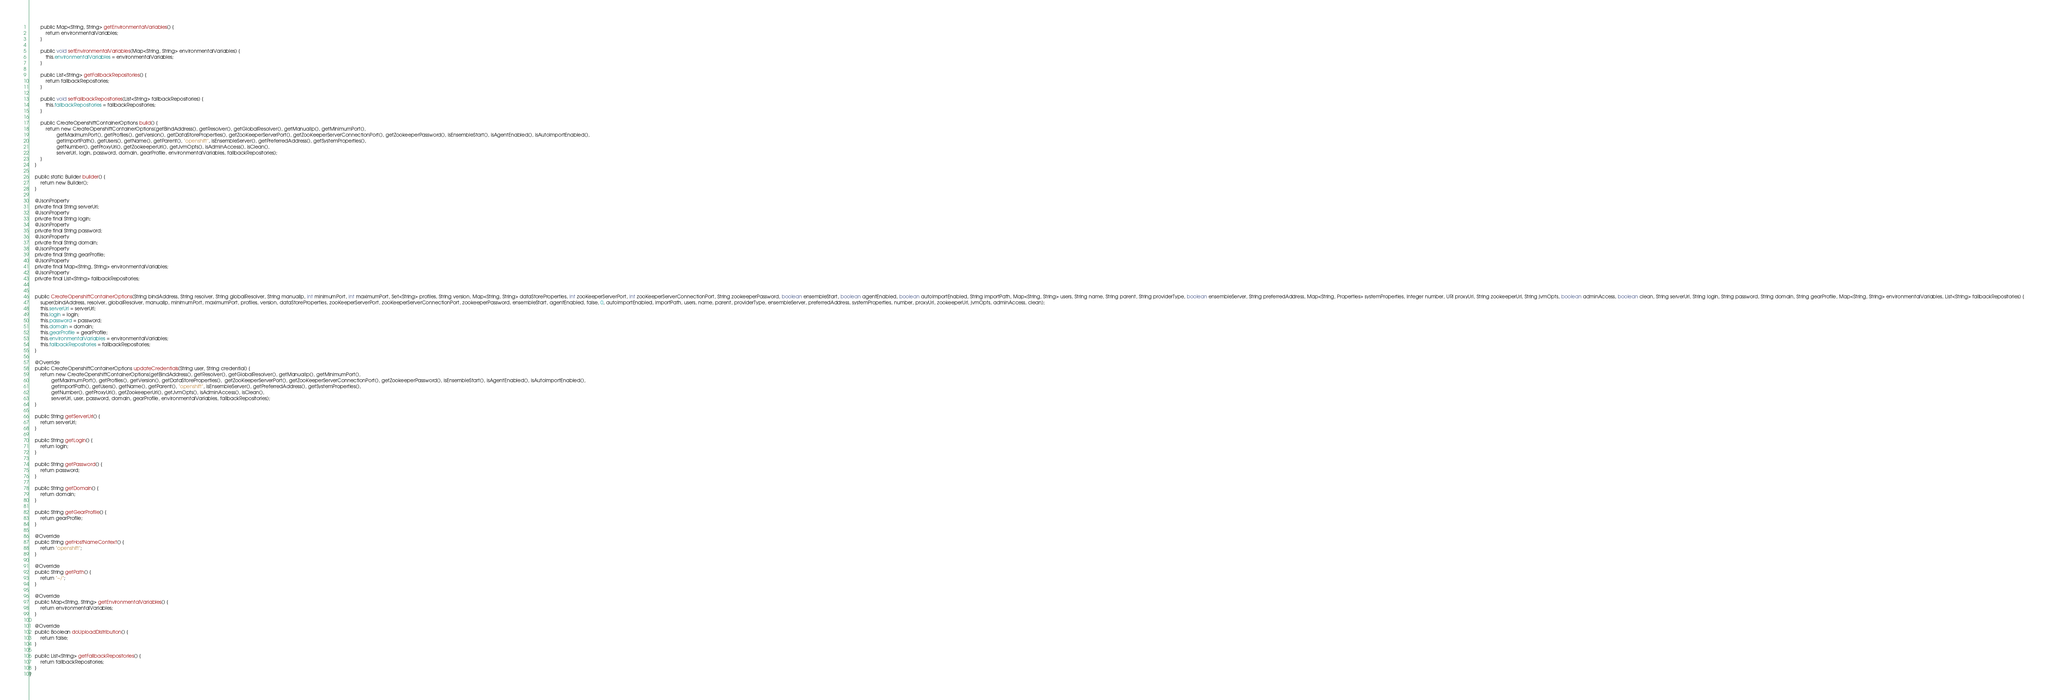<code> <loc_0><loc_0><loc_500><loc_500><_Java_>        public Map<String, String> getEnvironmentalVariables() {
            return environmentalVariables;
        }

        public void setEnvironmentalVariables(Map<String, String> environmentalVariables) {
            this.environmentalVariables = environmentalVariables;
        }

        public List<String> getFallbackRepositories() {
            return fallbackRepositories;
        }

        public void setFallbackRepositories(List<String> fallbackRepositories) {
            this.fallbackRepositories = fallbackRepositories;
        }

        public CreateOpenshiftContainerOptions build() {
            return new CreateOpenshiftContainerOptions(getBindAddress(), getResolver(), getGlobalResolver(), getManualIp(), getMinimumPort(),
                    getMaximumPort(), getProfiles(), getVersion(), getDataStoreProperties(), getZooKeeperServerPort(), getZooKeeperServerConnectionPort(), getZookeeperPassword(), isEnsembleStart(), isAgentEnabled(), isAutoImportEnabled(),
                    getImportPath(), getUsers(), getName(), getParent(), "openshift", isEnsembleServer(), getPreferredAddress(), getSystemProperties(),
                    getNumber(), getProxyUri(), getZookeeperUrl(), getJvmOpts(), isAdminAccess(), isClean(),
                    serverUrl, login, password, domain, gearProfile, environmentalVariables, fallbackRepositories);
        }
    }

    public static Builder builder() {
        return new Builder();
    }

    @JsonProperty
    private final String serverUrl;
    @JsonProperty
    private final String login;
    @JsonProperty
    private final String password;
    @JsonProperty
    private final String domain;
    @JsonProperty
    private final String gearProfile;
    @JsonProperty
    private final Map<String, String> environmentalVariables;
    @JsonProperty
    private final List<String> fallbackRepositories;


    public CreateOpenshiftContainerOptions(String bindAddress, String resolver, String globalResolver, String manualIp, int minimumPort, int maximumPort, Set<String> profiles, String version, Map<String, String> dataStoreProperties, int zooKeeperServerPort, int zooKeeperServerConnectionPort, String zookeeperPassword, boolean ensembleStart, boolean agentEnabled, boolean autoImportEnabled, String importPath, Map<String, String> users, String name, String parent, String providerType, boolean ensembleServer, String preferredAddress, Map<String, Properties> systemProperties, Integer number, URI proxyUri, String zookeeperUrl, String jvmOpts, boolean adminAccess, boolean clean, String serverUrl, String login, String password, String domain, String gearProfile, Map<String, String> environmentalVariables, List<String> fallbackRepositories) {
        super(bindAddress, resolver, globalResolver, manualIp, minimumPort, maximumPort, profiles, version, dataStoreProperties, zooKeeperServerPort, zooKeeperServerConnectionPort, zookeeperPassword, ensembleStart, agentEnabled, false, 0, autoImportEnabled, importPath, users, name, parent, providerType, ensembleServer, preferredAddress, systemProperties, number, proxyUri, zookeeperUrl, jvmOpts, adminAccess, clean);
        this.serverUrl = serverUrl;
        this.login = login;
        this.password = password;
        this.domain = domain;
        this.gearProfile = gearProfile;
        this.environmentalVariables = environmentalVariables;
        this.fallbackRepositories = fallbackRepositories;
    }

    @Override
    public CreateOpenshiftContainerOptions updateCredentials(String user, String credential) {
        return new CreateOpenshiftContainerOptions(getBindAddress(), getResolver(), getGlobalResolver(), getManualIp(), getMinimumPort(),
                getMaximumPort(), getProfiles(), getVersion(), getDataStoreProperties(),  getZooKeeperServerPort(), getZooKeeperServerConnectionPort(), getZookeeperPassword(), isEnsembleStart(), isAgentEnabled(), isAutoImportEnabled(),
                getImportPath(), getUsers(), getName(), getParent(), "openshift", isEnsembleServer(), getPreferredAddress(), getSystemProperties(),
                getNumber(), getProxyUri(), getZookeeperUrl(), getJvmOpts(), isAdminAccess(), isClean(),
                serverUrl, user, password, domain, gearProfile, environmentalVariables, fallbackRepositories);
    }

    public String getServerUrl() {
        return serverUrl;
    }

    public String getLogin() {
        return login;
    }

    public String getPassword() {
        return password;
    }

    public String getDomain() {
        return domain;
    }

    public String getGearProfile() {
        return gearProfile;
    }

    @Override
    public String getHostNameContext() {
        return "openshift";
    }

    @Override
    public String getPath() {
        return "~/";
    }

    @Override
    public Map<String, String> getEnvironmentalVariables() {
        return environmentalVariables;
    }

    @Override
    public Boolean doUploadDistribution() {
        return false;
    }

    public List<String> getFallbackRepositories() {
        return fallbackRepositories;
    }
}
</code> 